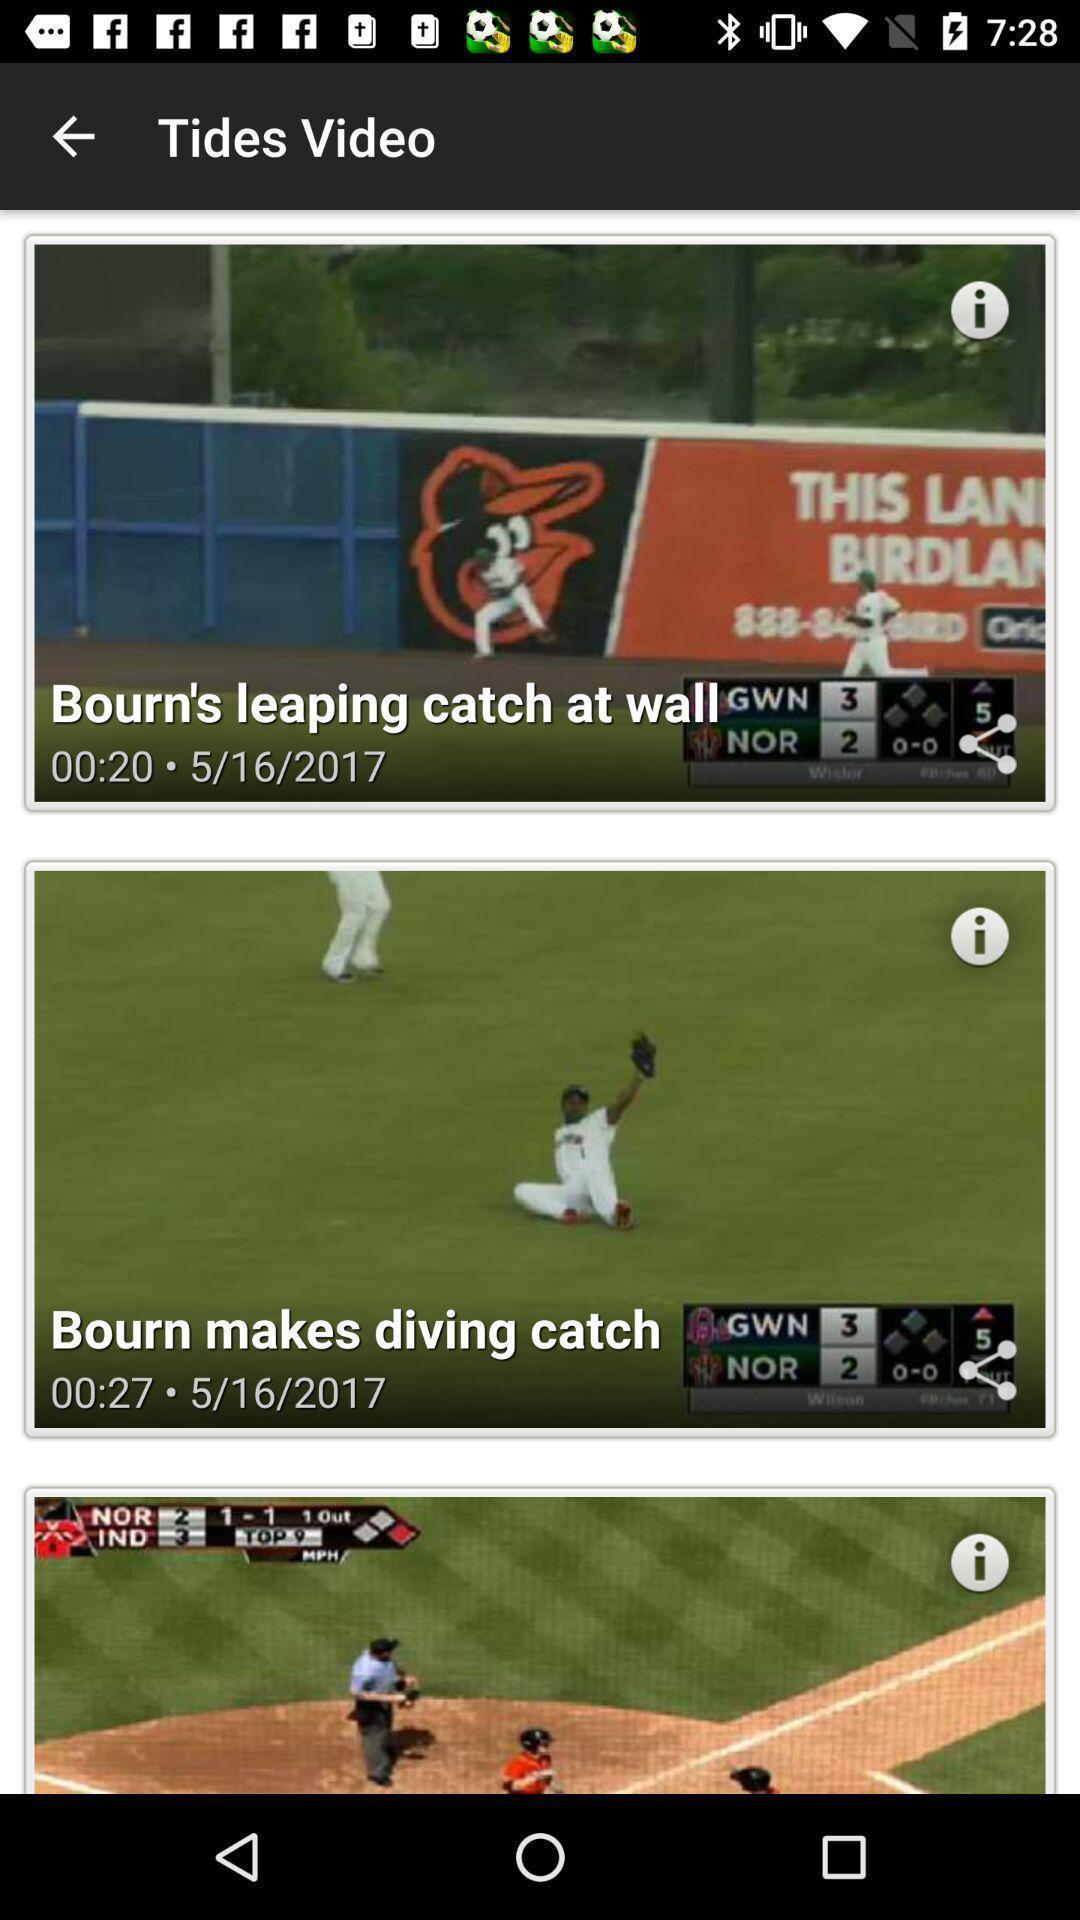Provide a description of this screenshot. Videos of baseball are displaying. 